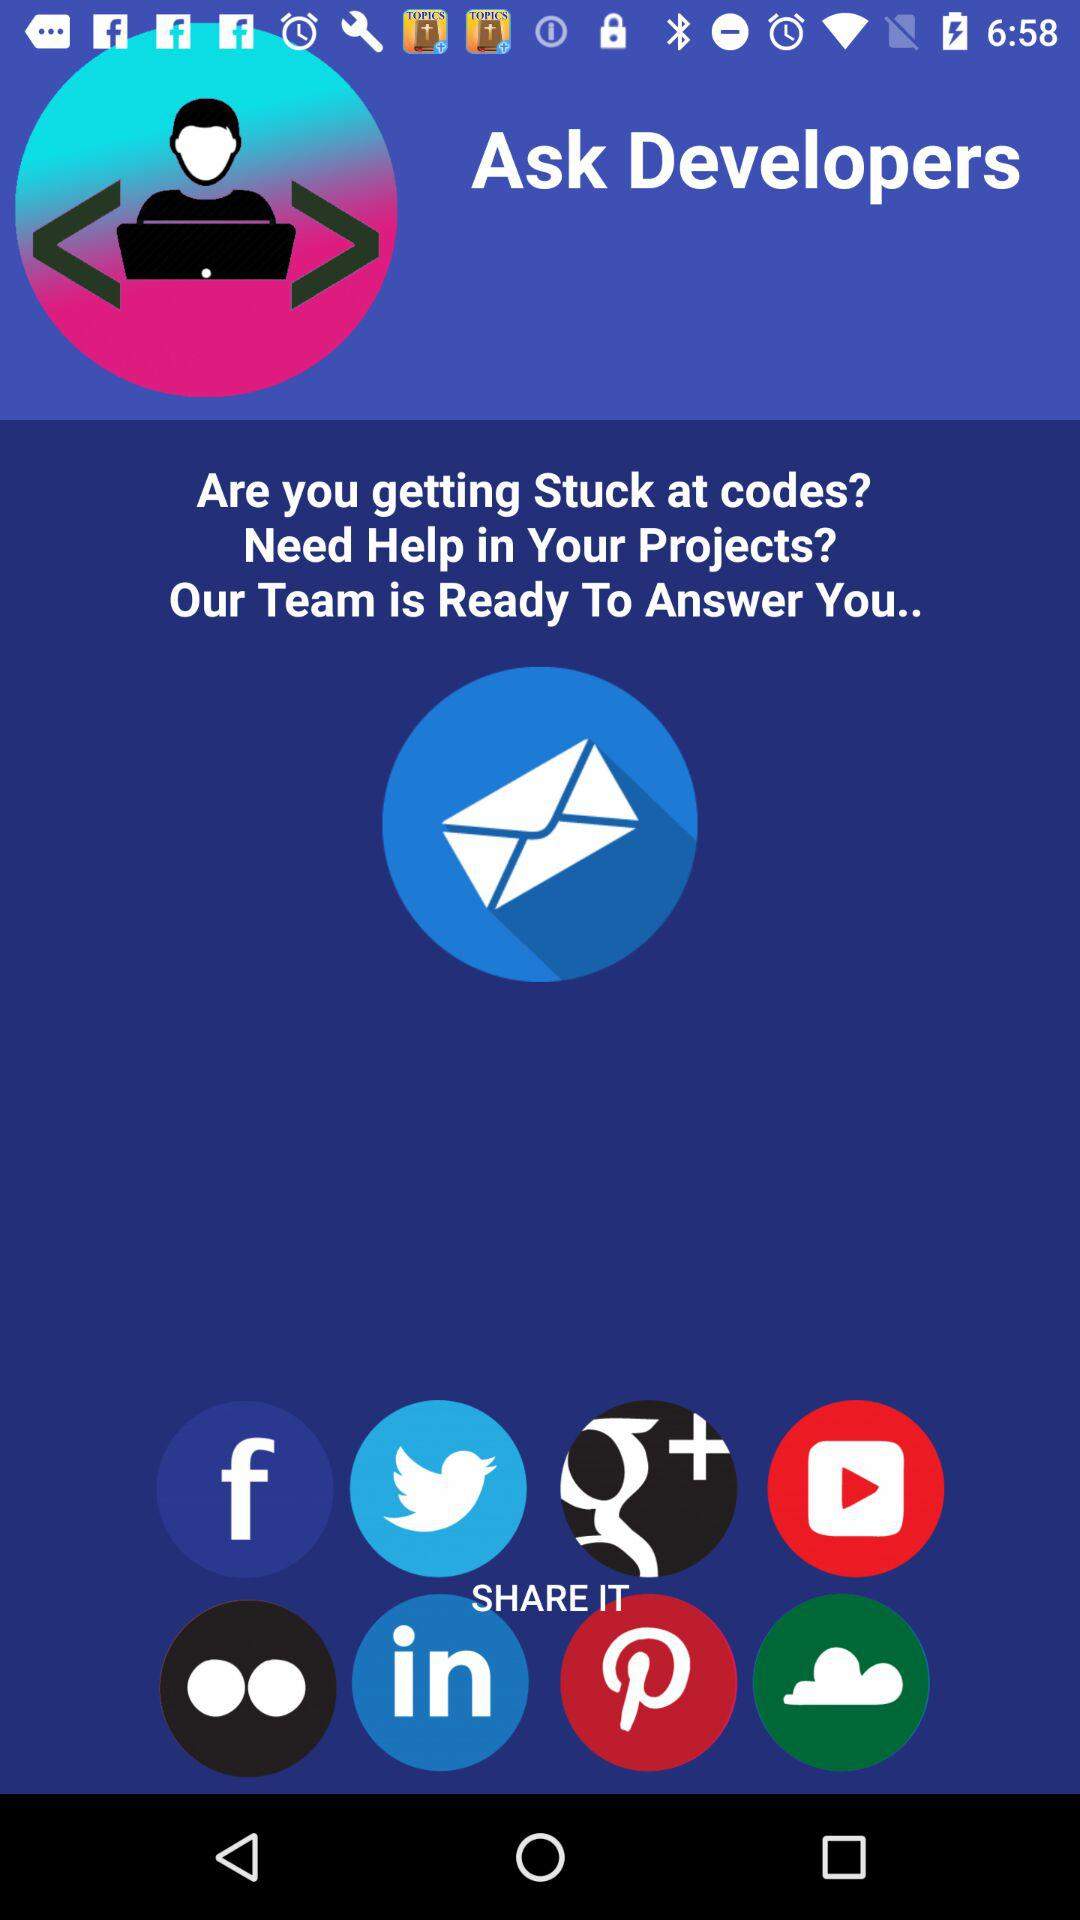What are the sharing options? The sharing options are "Facebook", "Twitter", "Google+", "YouTube", "Flickr", "LinkedIn", "Pinterest" and "Cloud". 